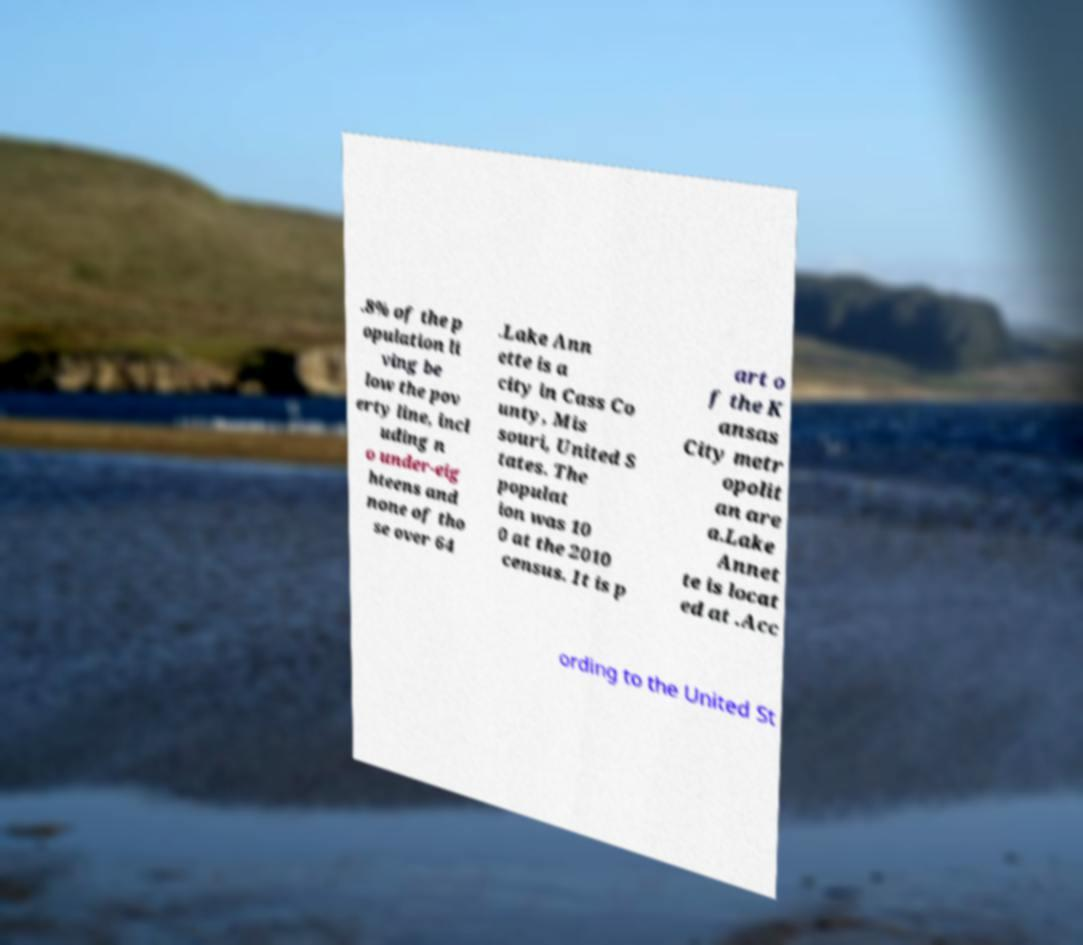Please identify and transcribe the text found in this image. .8% of the p opulation li ving be low the pov erty line, incl uding n o under-eig hteens and none of tho se over 64 .Lake Ann ette is a city in Cass Co unty, Mis souri, United S tates. The populat ion was 10 0 at the 2010 census. It is p art o f the K ansas City metr opolit an are a.Lake Annet te is locat ed at .Acc ording to the United St 